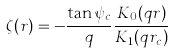Convert formula to latex. <formula><loc_0><loc_0><loc_500><loc_500>\zeta ( r ) = - \frac { \tan \psi _ { c } } { q } \frac { K _ { 0 } ( q r ) } { K _ { 1 } ( q r _ { c } ) }</formula> 